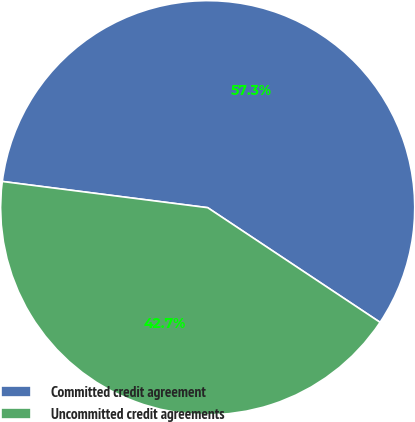Convert chart. <chart><loc_0><loc_0><loc_500><loc_500><pie_chart><fcel>Committed credit agreement<fcel>Uncommitted credit agreements<nl><fcel>57.32%<fcel>42.68%<nl></chart> 